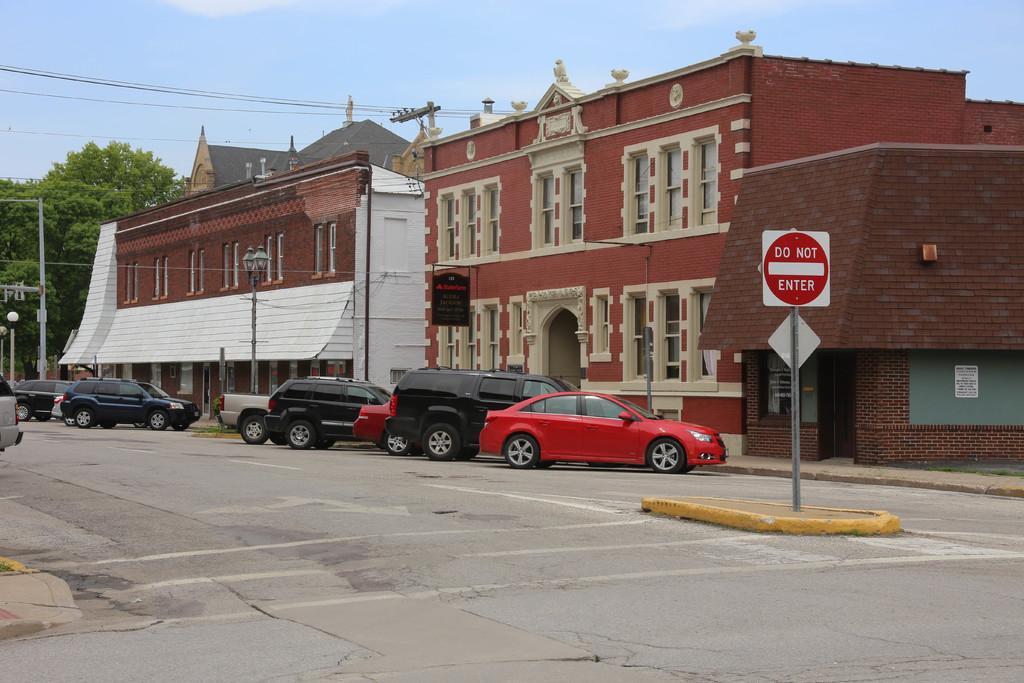Please provide a concise description of this image. In the image we can see the building and the windows of the building. There are even vehicles of different colors, here we can see the poles and boards. There are even electric poles and electric wires. Here we can see the road, trees and the sky. 